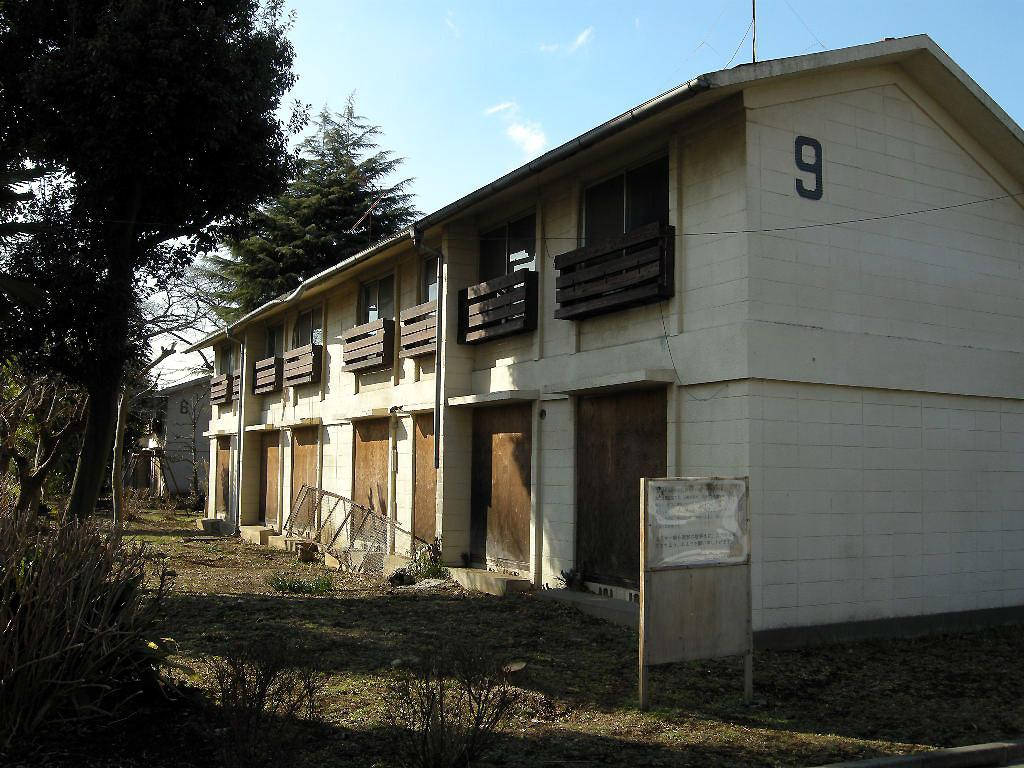What structure is located on the left side of the image? There is a building on the left side of the image. What type of vegetation is in front of the building on the right side? There are trees in front of the building on the right side. What is in the middle of the image? There is a board in the middle of the image. What is visible above the image? The sky is visible above the image. What can be seen in the sky? Clouds are present in the sky. How many gloves are hanging from the trees in the image? There are no gloves present in the image; it features a building, trees, a board, and clouds in the sky. Are there any boots visible in the image? There are no boots present in the image. 